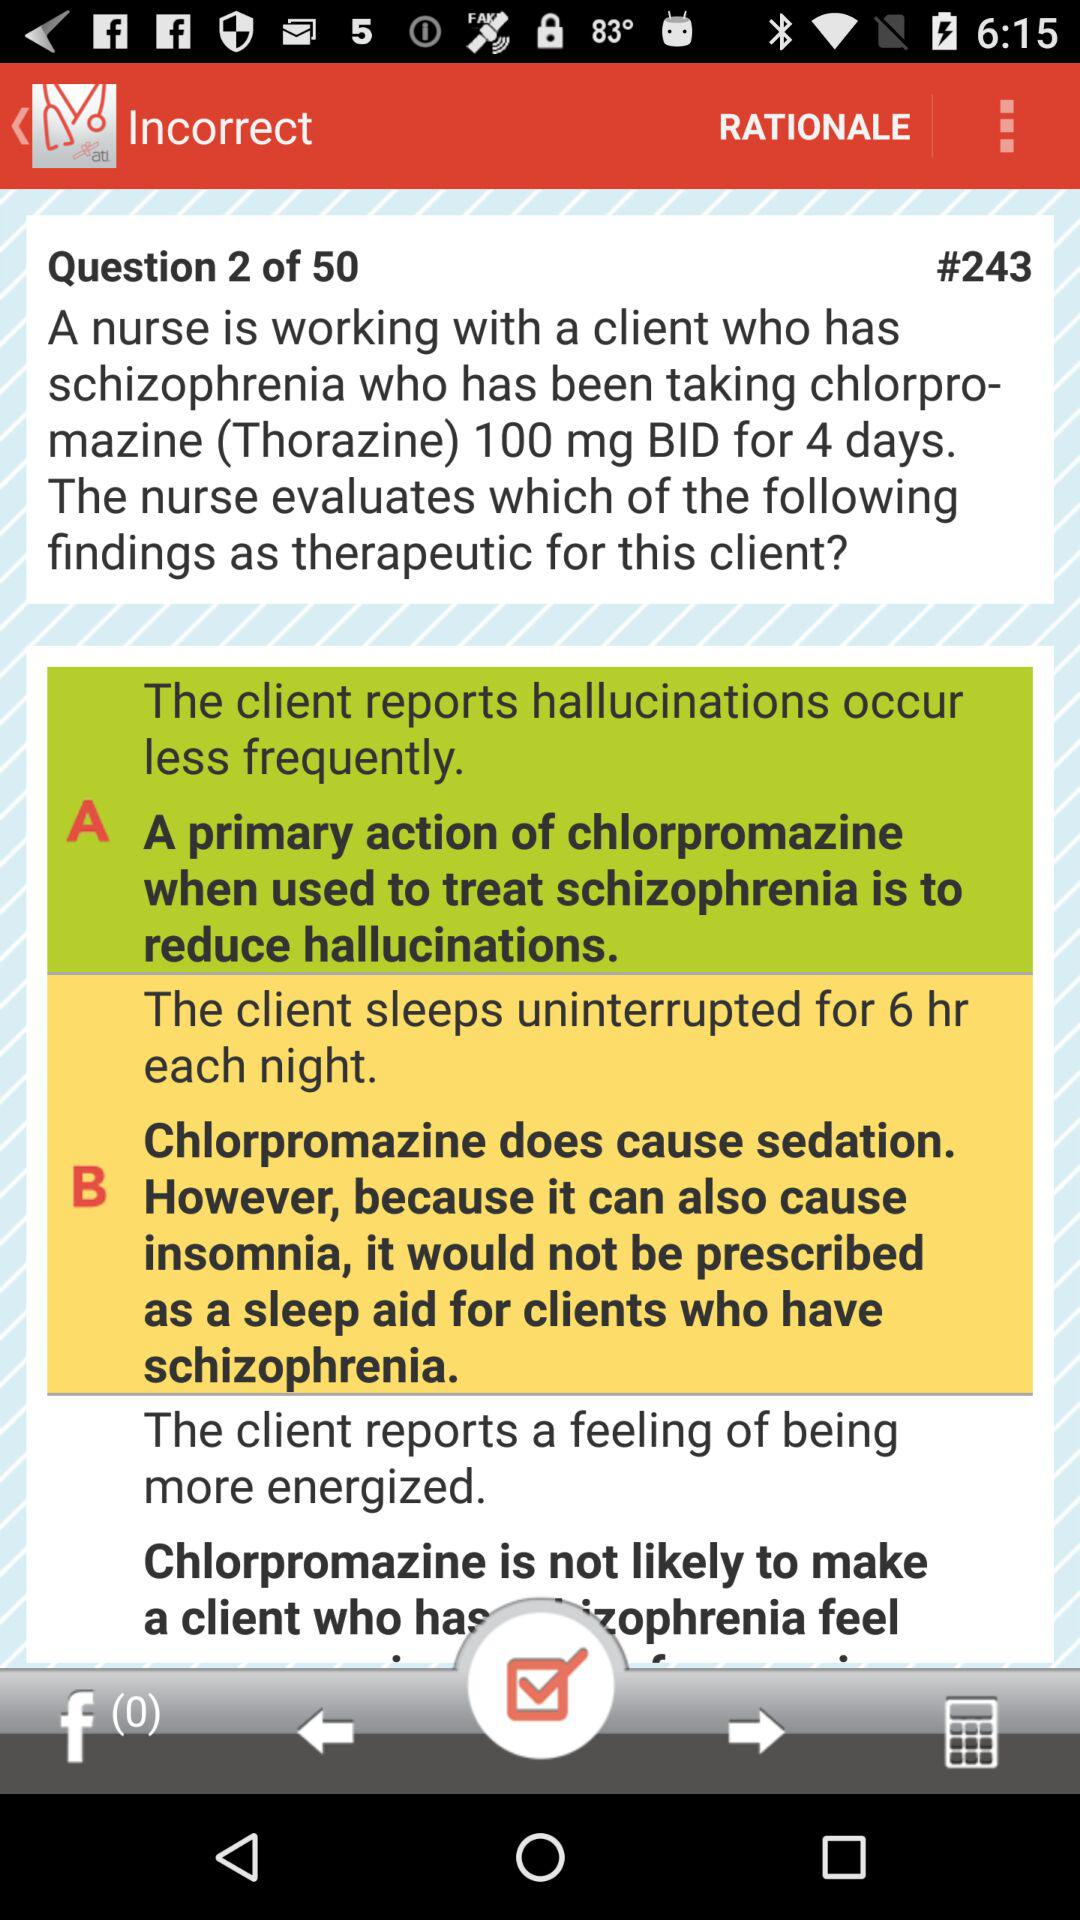How many of the therapeutic findings are supported by the text?
Answer the question using a single word or phrase. 2 